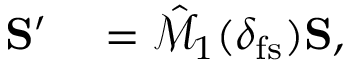Convert formula to latex. <formula><loc_0><loc_0><loc_500><loc_500>\begin{array} { r l } { { S } ^ { \prime } } & = \hat { \mathcal { M } } _ { 1 } ( \delta _ { f s } ) { S } , } \end{array}</formula> 